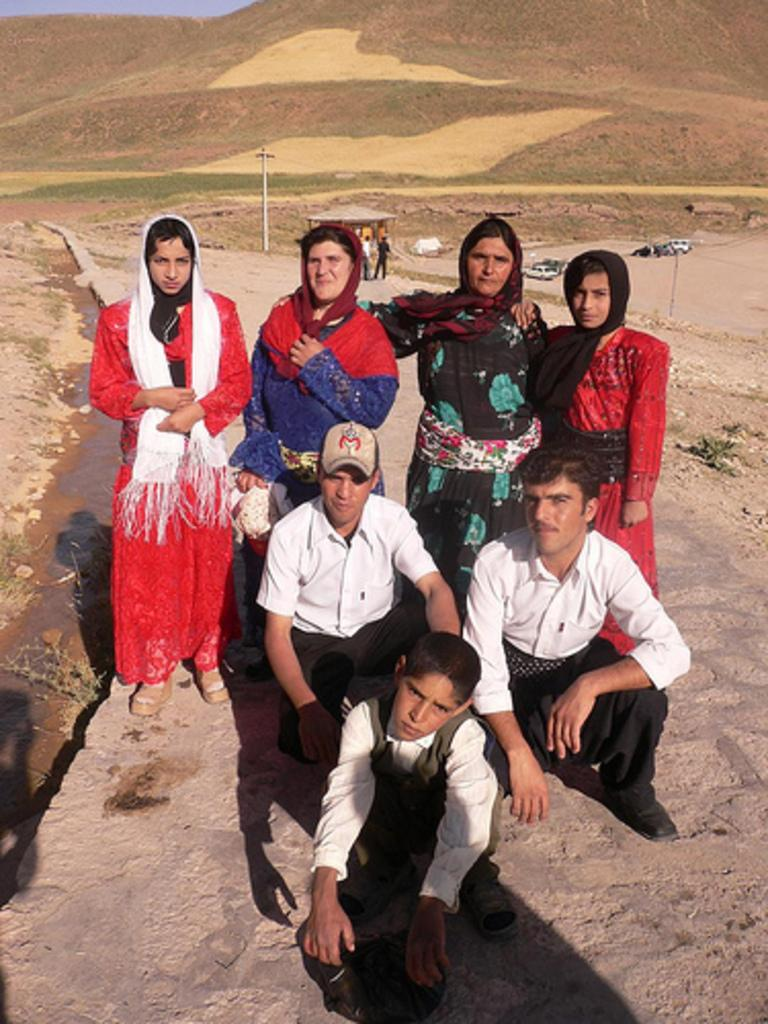Who or what is present in the image? There are people in the image. What can be seen in the background of the image? There is a pole, vehicles, a mountain, and the sky visible in the background of the image. What is the price of the jar in the image? There is no jar present in the image, so it is not possible to determine its price. 